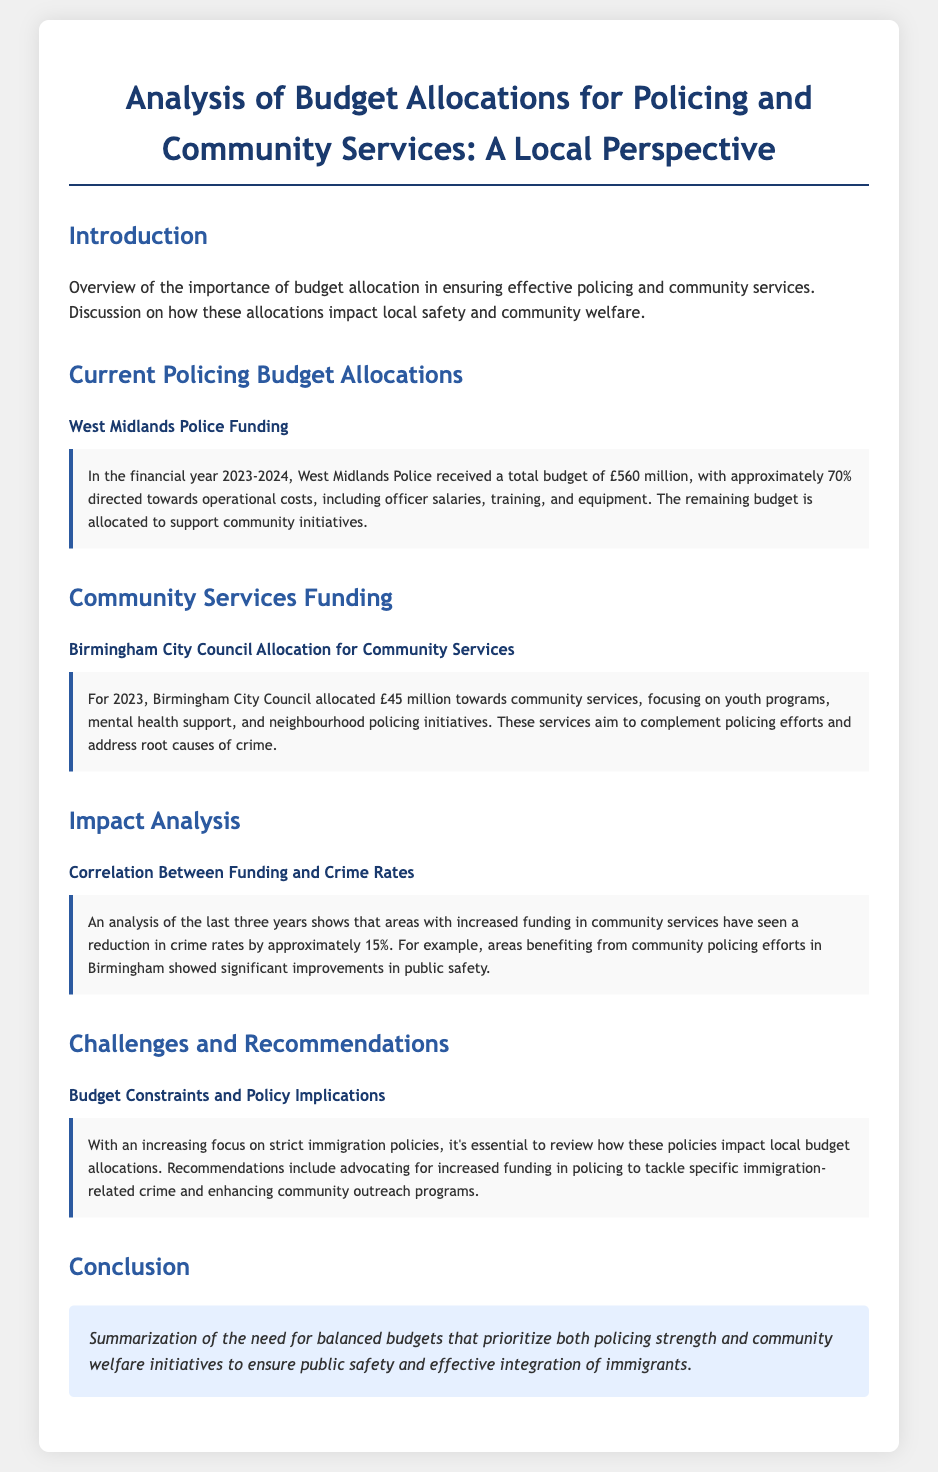what is the total budget for West Midlands Police? The document states that West Midlands Police received a total budget of £560 million for the financial year 2023-2024.
Answer: £560 million how much of the police budget is directed towards operational costs? The document indicates that approximately 70% of the budget is directed towards operational costs.
Answer: 70% what is the amount allocated by Birmingham City Council for community services in 2023? The document mentions that Birmingham City Council allocated £45 million towards community services.
Answer: £45 million what percentage reduction in crime rates was observed in areas with increased community services funding? According to the document, areas with increased funding in community services saw a reduction in crime rates by approximately 15%.
Answer: 15% which specific community services are highlighted in the funding allocation? The services mentioned in the document include youth programs, mental health support, and neighbourhood policing initiatives.
Answer: youth programs, mental health support, neighbourhood policing initiatives what recommendation does the document make regarding immigration policy? The document recommends advocating for increased funding in policing to tackle specific immigration-related crime and enhancing community outreach programs.
Answer: increased funding in policing what is the purpose of community services according to the document? The document states that these services aim to complement policing efforts and address root causes of crime.
Answer: complement policing efforts and address root causes of crime how are public safety improvements measured in the document? The document measures improvements in public safety by analyzing crime rates in areas benefiting from community policing efforts in Birmingham.
Answer: analyzing crime rates 